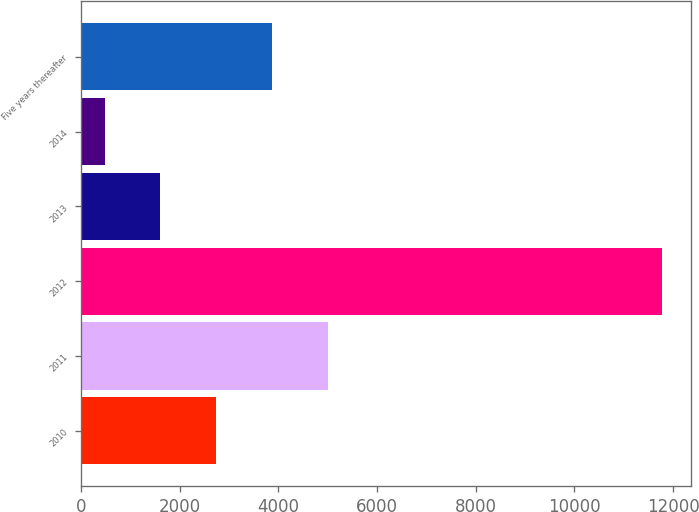Convert chart. <chart><loc_0><loc_0><loc_500><loc_500><bar_chart><fcel>2010<fcel>2011<fcel>2012<fcel>2013<fcel>2014<fcel>Five years thereafter<nl><fcel>2740.2<fcel>5000.4<fcel>11781<fcel>1610.1<fcel>480<fcel>3870.3<nl></chart> 